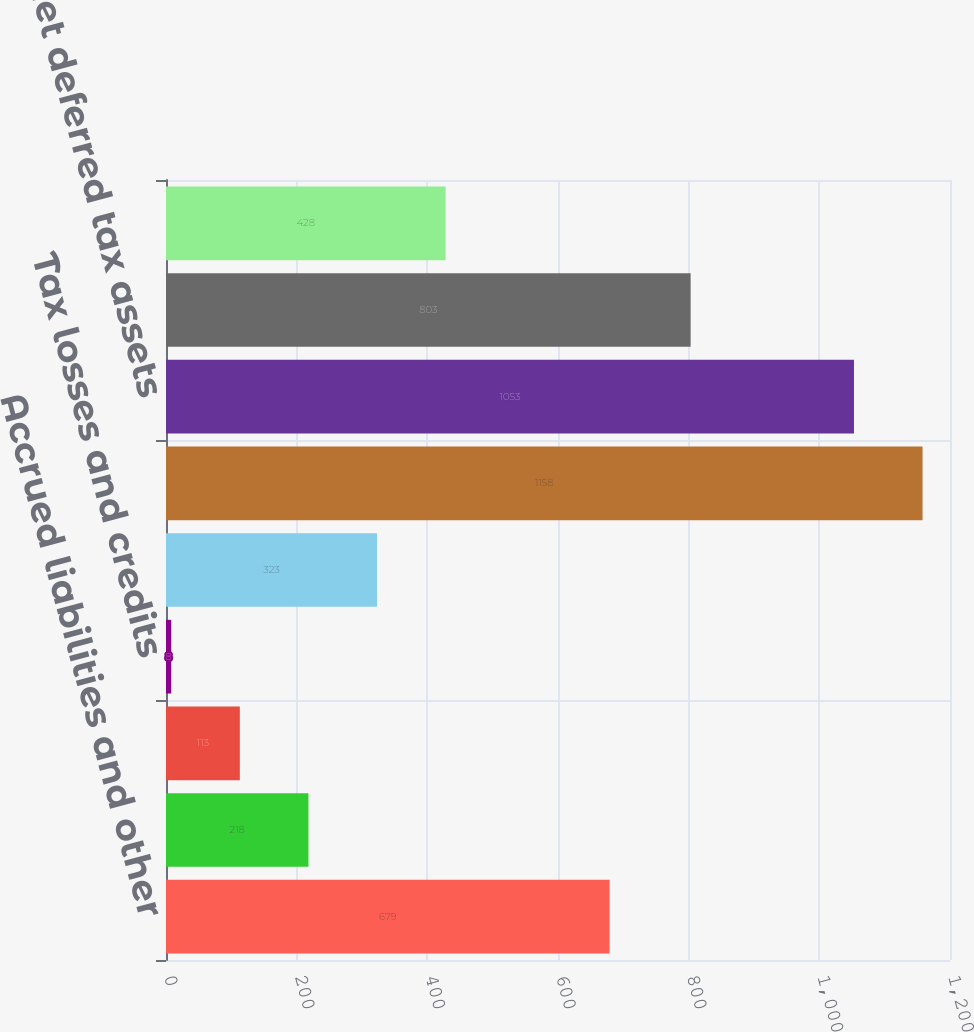<chart> <loc_0><loc_0><loc_500><loc_500><bar_chart><fcel>Accrued liabilities and other<fcel>Basis of capital assets and<fcel>Accounts receivable and<fcel>Tax losses and credits<fcel>Other<fcel>Total deferred tax assets<fcel>Net deferred tax assets<fcel>Deferred tax<fcel>Net deferred tax asset<nl><fcel>679<fcel>218<fcel>113<fcel>8<fcel>323<fcel>1158<fcel>1053<fcel>803<fcel>428<nl></chart> 